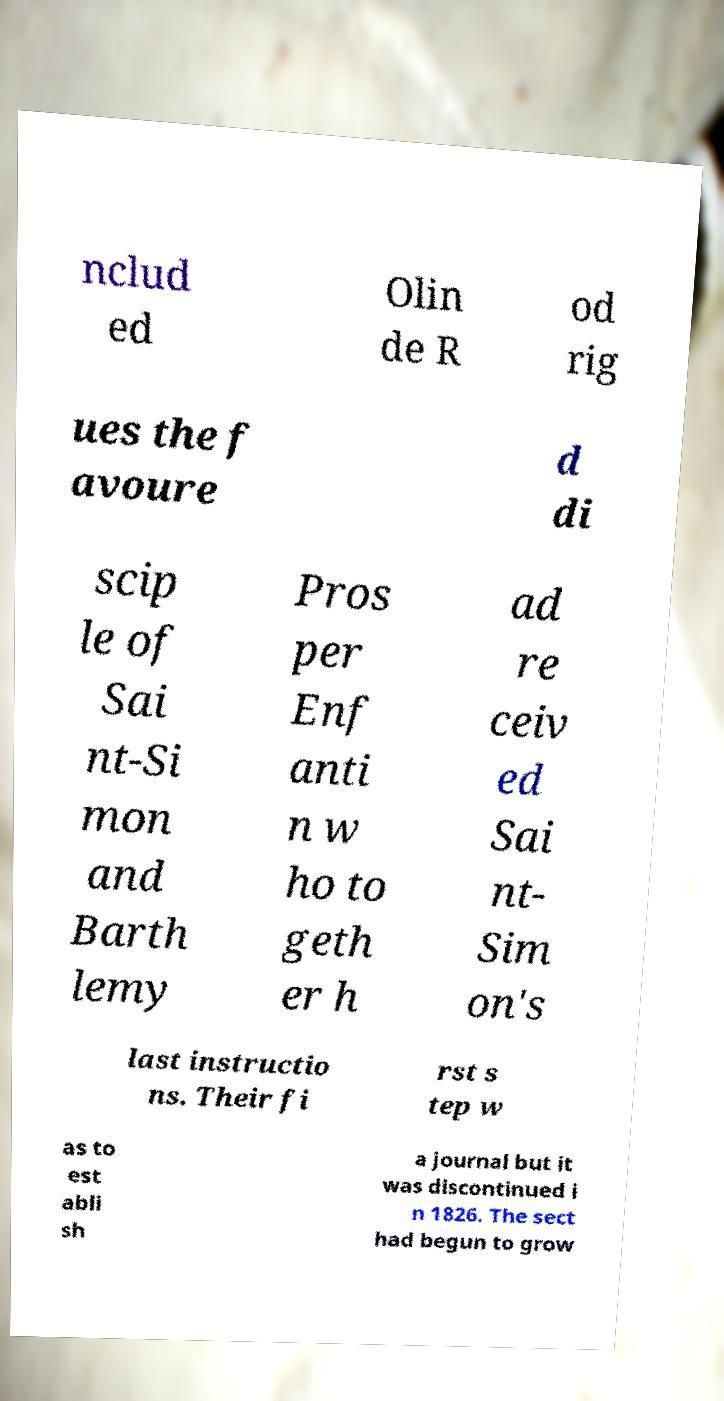Please read and relay the text visible in this image. What does it say? nclud ed Olin de R od rig ues the f avoure d di scip le of Sai nt-Si mon and Barth lemy Pros per Enf anti n w ho to geth er h ad re ceiv ed Sai nt- Sim on's last instructio ns. Their fi rst s tep w as to est abli sh a journal but it was discontinued i n 1826. The sect had begun to grow 